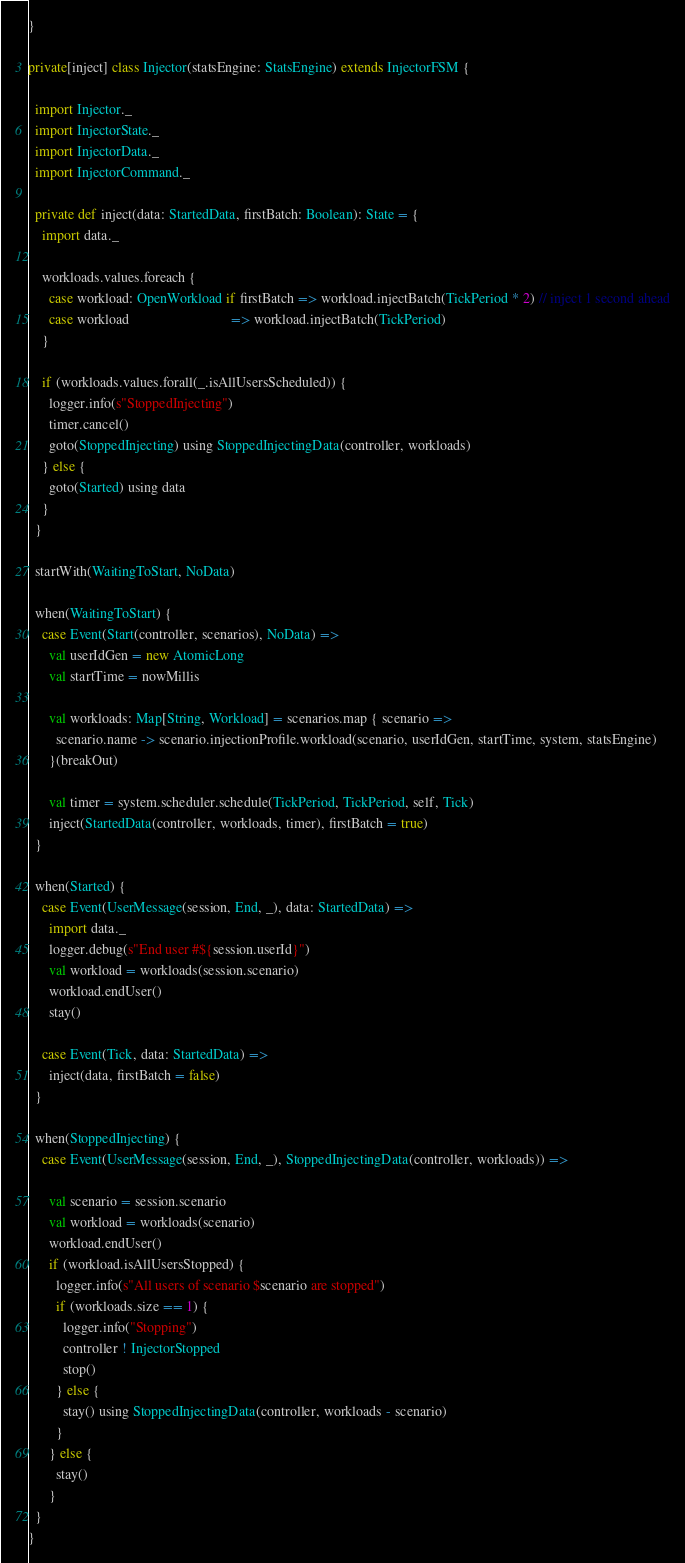<code> <loc_0><loc_0><loc_500><loc_500><_Scala_>}

private[inject] class Injector(statsEngine: StatsEngine) extends InjectorFSM {

  import Injector._
  import InjectorState._
  import InjectorData._
  import InjectorCommand._

  private def inject(data: StartedData, firstBatch: Boolean): State = {
    import data._

    workloads.values.foreach {
      case workload: OpenWorkload if firstBatch => workload.injectBatch(TickPeriod * 2) // inject 1 second ahead
      case workload                             => workload.injectBatch(TickPeriod)
    }

    if (workloads.values.forall(_.isAllUsersScheduled)) {
      logger.info(s"StoppedInjecting")
      timer.cancel()
      goto(StoppedInjecting) using StoppedInjectingData(controller, workloads)
    } else {
      goto(Started) using data
    }
  }

  startWith(WaitingToStart, NoData)

  when(WaitingToStart) {
    case Event(Start(controller, scenarios), NoData) =>
      val userIdGen = new AtomicLong
      val startTime = nowMillis

      val workloads: Map[String, Workload] = scenarios.map { scenario =>
        scenario.name -> scenario.injectionProfile.workload(scenario, userIdGen, startTime, system, statsEngine)
      }(breakOut)

      val timer = system.scheduler.schedule(TickPeriod, TickPeriod, self, Tick)
      inject(StartedData(controller, workloads, timer), firstBatch = true)
  }

  when(Started) {
    case Event(UserMessage(session, End, _), data: StartedData) =>
      import data._
      logger.debug(s"End user #${session.userId}")
      val workload = workloads(session.scenario)
      workload.endUser()
      stay()

    case Event(Tick, data: StartedData) =>
      inject(data, firstBatch = false)
  }

  when(StoppedInjecting) {
    case Event(UserMessage(session, End, _), StoppedInjectingData(controller, workloads)) =>

      val scenario = session.scenario
      val workload = workloads(scenario)
      workload.endUser()
      if (workload.isAllUsersStopped) {
        logger.info(s"All users of scenario $scenario are stopped")
        if (workloads.size == 1) {
          logger.info("Stopping")
          controller ! InjectorStopped
          stop()
        } else {
          stay() using StoppedInjectingData(controller, workloads - scenario)
        }
      } else {
        stay()
      }
  }
}
</code> 